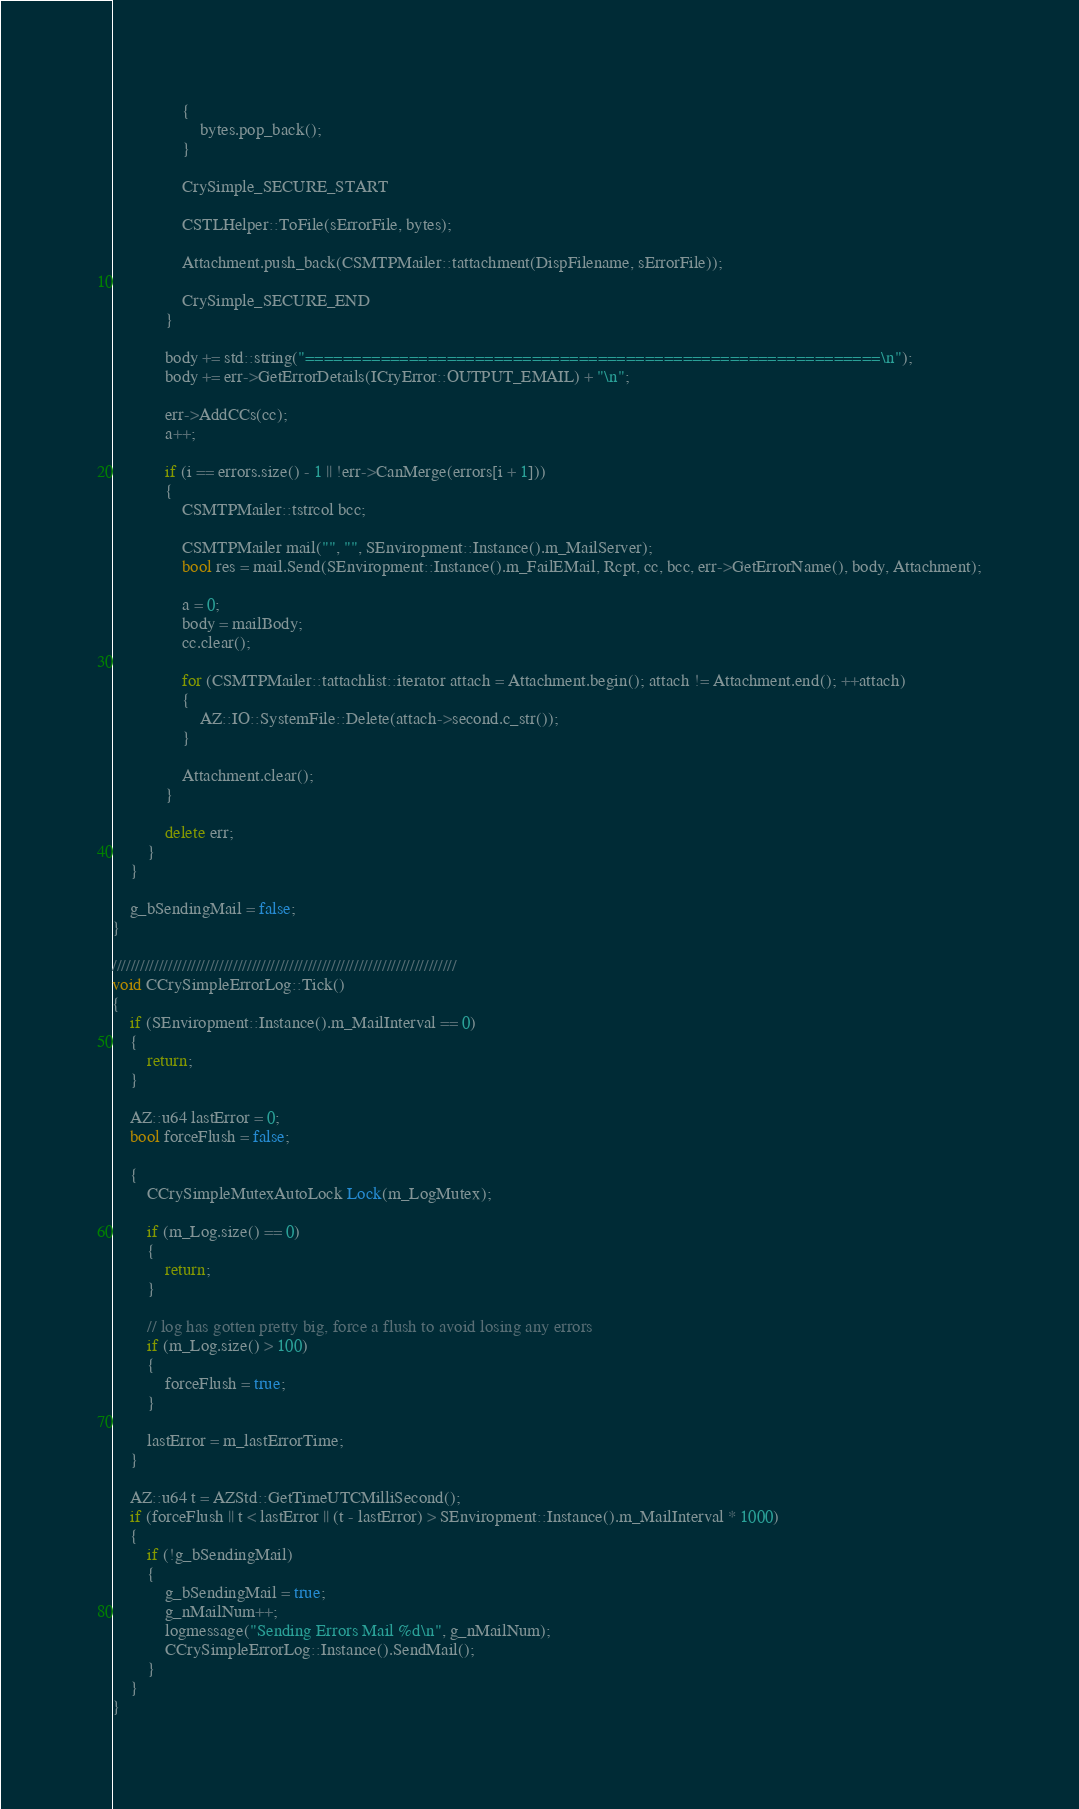Convert code to text. <code><loc_0><loc_0><loc_500><loc_500><_C++_>                {
                    bytes.pop_back();
                }

                CrySimple_SECURE_START

                CSTLHelper::ToFile(sErrorFile, bytes);

                Attachment.push_back(CSMTPMailer::tattachment(DispFilename, sErrorFile));

                CrySimple_SECURE_END
            }

            body += std::string("=============================================================\n");
            body += err->GetErrorDetails(ICryError::OUTPUT_EMAIL) + "\n";

            err->AddCCs(cc);
            a++;

            if (i == errors.size() - 1 || !err->CanMerge(errors[i + 1]))
            {
                CSMTPMailer::tstrcol bcc;

                CSMTPMailer mail("", "", SEnviropment::Instance().m_MailServer);
                bool res = mail.Send(SEnviropment::Instance().m_FailEMail, Rcpt, cc, bcc, err->GetErrorName(), body, Attachment);

                a = 0;
                body = mailBody;
                cc.clear();

                for (CSMTPMailer::tattachlist::iterator attach = Attachment.begin(); attach != Attachment.end(); ++attach)
                {
                    AZ::IO::SystemFile::Delete(attach->second.c_str());
                }

                Attachment.clear();
            }

            delete err;
        }
    }

    g_bSendingMail = false;
}

//////////////////////////////////////////////////////////////////////////
void CCrySimpleErrorLog::Tick()
{
    if (SEnviropment::Instance().m_MailInterval == 0)
    {
        return;
    }

    AZ::u64 lastError = 0;
    bool forceFlush = false;

    {
        CCrySimpleMutexAutoLock Lock(m_LogMutex);

        if (m_Log.size() == 0)
        {
            return;
        }

        // log has gotten pretty big, force a flush to avoid losing any errors
        if (m_Log.size() > 100)
        {
            forceFlush = true;
        }

        lastError = m_lastErrorTime;
    }

    AZ::u64 t = AZStd::GetTimeUTCMilliSecond();
    if (forceFlush || t < lastError || (t - lastError) > SEnviropment::Instance().m_MailInterval * 1000)
    {
        if (!g_bSendingMail)
        {
            g_bSendingMail = true;
            g_nMailNum++;
            logmessage("Sending Errors Mail %d\n", g_nMailNum);
            CCrySimpleErrorLog::Instance().SendMail();
        }
    }
}
</code> 